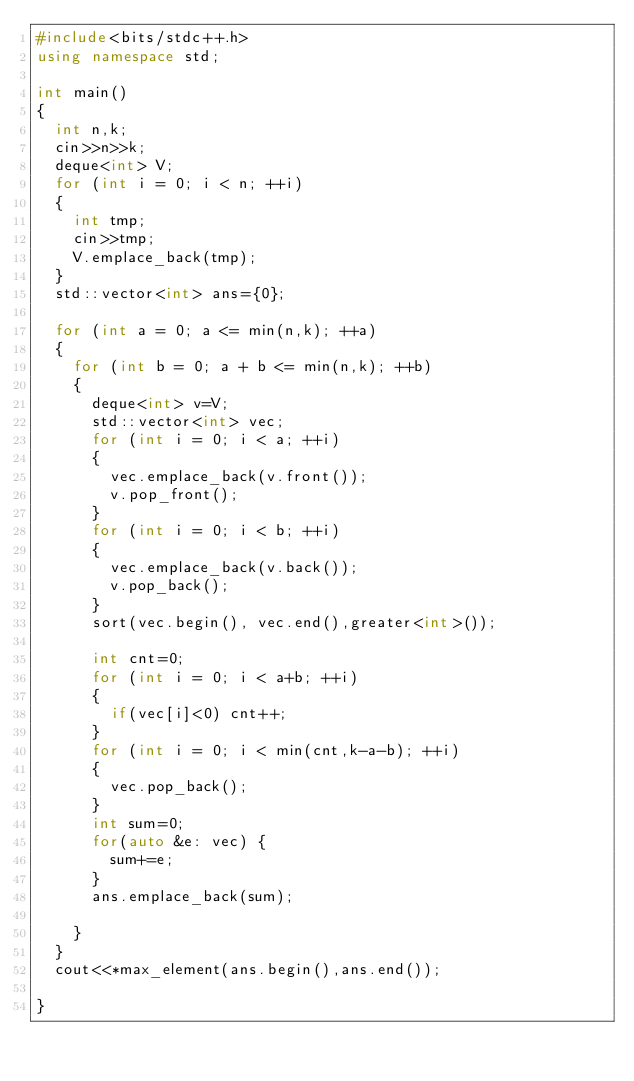<code> <loc_0><loc_0><loc_500><loc_500><_C++_>#include<bits/stdc++.h>
using namespace std;

int main()
{
  int n,k;
  cin>>n>>k;
  deque<int> V;
  for (int i = 0; i < n; ++i)
  {
    int tmp;
    cin>>tmp;
    V.emplace_back(tmp);
  }
  std::vector<int> ans={0};
  
  for (int a = 0; a <= min(n,k); ++a)
  {
    for (int b = 0; a + b <= min(n,k); ++b)
    {
      deque<int> v=V; 
      std::vector<int> vec;
      for (int i = 0; i < a; ++i)
      {
        vec.emplace_back(v.front());
        v.pop_front();
      }
      for (int i = 0; i < b; ++i)
      {
        vec.emplace_back(v.back());
        v.pop_back();
      }
      sort(vec.begin(), vec.end(),greater<int>());
      
      int cnt=0;
      for (int i = 0; i < a+b; ++i)
      {
        if(vec[i]<0) cnt++;
      }
      for (int i = 0; i < min(cnt,k-a-b); ++i)
      {
        vec.pop_back();
      }
      int sum=0;
      for(auto &e: vec) {
        sum+=e;
      }
      ans.emplace_back(sum);
      
    }
  }
  cout<<*max_element(ans.begin(),ans.end());
  
}</code> 